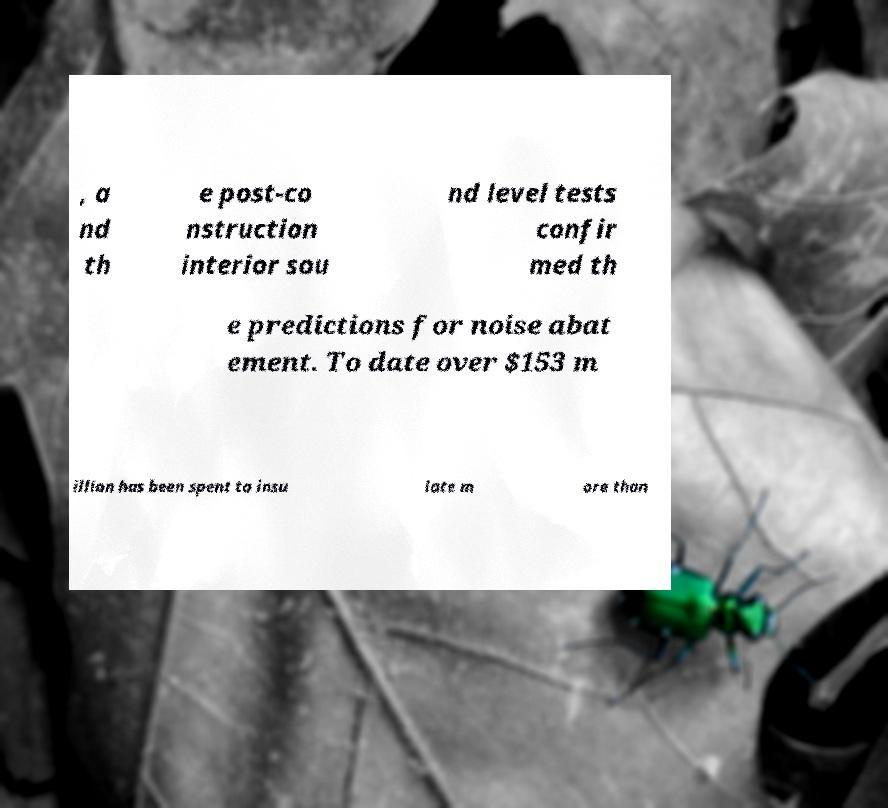Please read and relay the text visible in this image. What does it say? , a nd th e post-co nstruction interior sou nd level tests confir med th e predictions for noise abat ement. To date over $153 m illion has been spent to insu late m ore than 